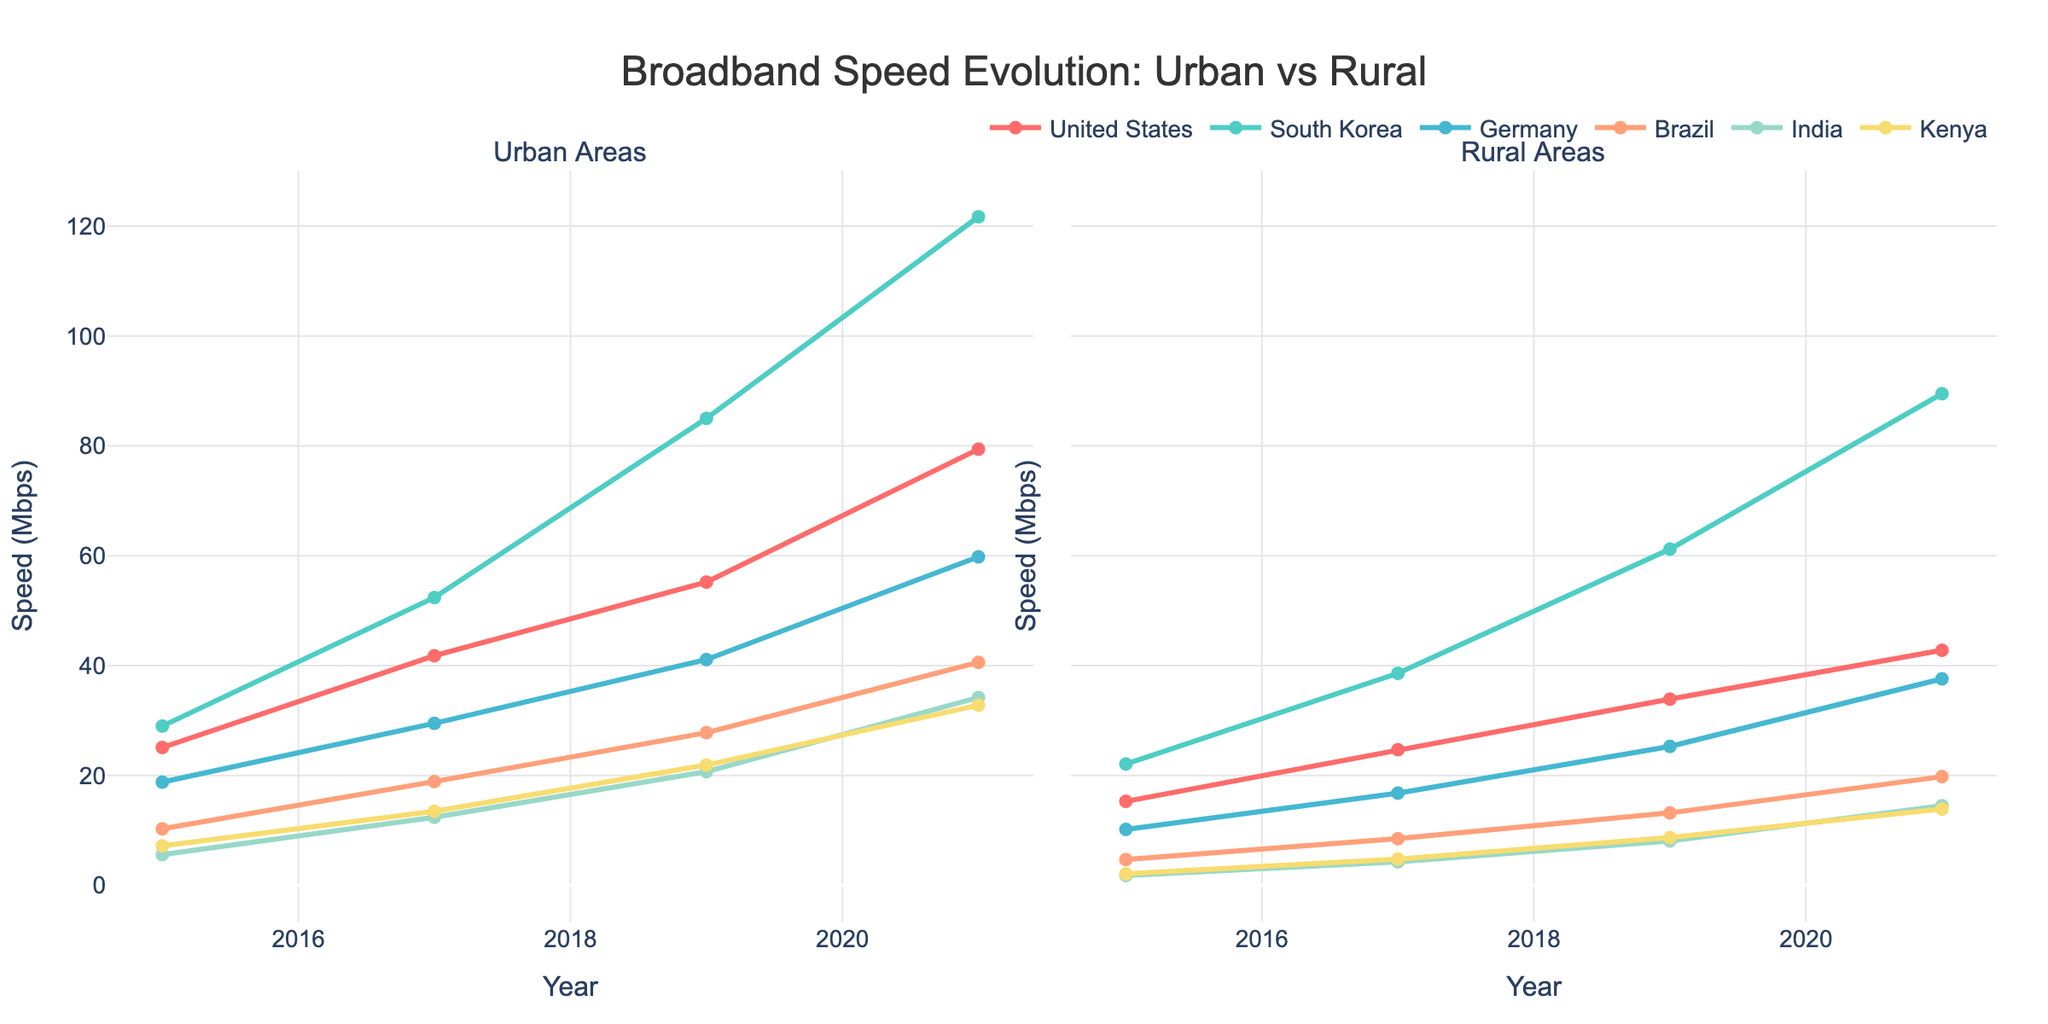Which country had the highest urban broadband speed in 2021? Look at the line chart for urban areas and check the endpoints for 2021. South Korea has the highest value at 121.7 Mbps.
Answer: South Korea Did rural broadband speeds in any country exceed 40 Mbps by 2021? Refer to the rural areas line chart and check the endpoints for each country in 2021. Only South Korea's rural broadband speed exceeded 40 Mbps and reached 89.5 Mbps.
Answer: South Korea Which country had the smallest increase in urban broadband speed between 2015 and 2021? Subtract the 2015 values from the 2021 values for urban broadband speed for each country. India shows the smallest increase: 34.2 - 5.6 = 28.6 Mbps.
Answer: India Between 2019 and 2021, which country saw the largest increase in rural broadband speed? Subtract the 2019 values from the 2021 values for rural broadband speed for each country. South Korea had the largest increase: 89.5 - 61.2 = 28.3 Mbps.
Answer: South Korea Compare the urban broadband speeds of Brazil and Kenya in 2019. Which one was faster? Check the urban areas line chart for 2019 and compare Kenya and Brazil. Brazil has a higher speed (27.8 Mbps) compared to Kenya (21.9 Mbps).
Answer: Brazil What is the difference in rural broadband speed between the United States and Germany in 2017? Check the rural areas line chart for 2017 and find the values for the United States (24.7 Mbps) and Germany (16.8 Mbps). The difference is 24.7 - 16.8 = 7.9 Mbps.
Answer: 7.9 Mbps Did any country have equal urban and rural broadband speeds in any given year? Examine each pair of urban and rural values for all countries across all years. None of the pairs are equal in any year.
Answer: No Which country showed the most consistent (steady) growth in urban broadband speed over the years? Look for the country whose urban line plot shows the most straight-line trend without sharp changes. Germany shows a consistent and steady growth.
Answer: Germany What is the combined rural broadband speed for India and Brazil in 2015? Sum the 2015 values for rural broadband speed for India (1.8 Mbps) and Brazil (4.7 Mbps). 1.8 + 4.7 = 6.5 Mbps.
Answer: 6.5 Mbps Who had a higher rural broadband speed in 2015, India or Kenya? Look at the rural areas line chart for 2015 and compare India (1.8 Mbps) with Kenya (2.1 Mbps). Kenya is higher.
Answer: Kenya 